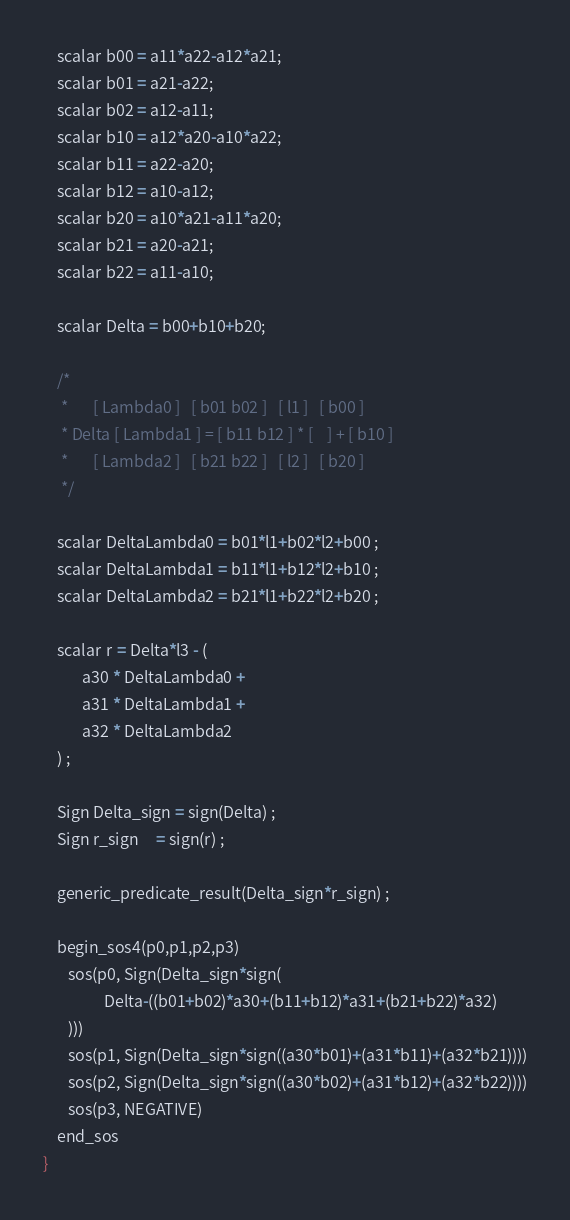Convert code to text. <code><loc_0><loc_0><loc_500><loc_500><_SQL_>
    scalar b00 = a11*a22-a12*a21;
    scalar b01 = a21-a22;
    scalar b02 = a12-a11;
    scalar b10 = a12*a20-a10*a22;
    scalar b11 = a22-a20;
    scalar b12 = a10-a12;
    scalar b20 = a10*a21-a11*a20;
    scalar b21 = a20-a21;
    scalar b22 = a11-a10;

    scalar Delta = b00+b10+b20;

    /*
     *       [ Lambda0 ]   [ b01 b02 ]   [ l1 ]   [ b00 ]
     * Delta [ Lambda1 ] = [ b11 b12 ] * [    ] + [ b10 ]
     *       [ Lambda2 ]   [ b21 b22 ]   [ l2 ]   [ b20 ]
     */

    scalar DeltaLambda0 = b01*l1+b02*l2+b00 ;
    scalar DeltaLambda1 = b11*l1+b12*l2+b10 ;
    scalar DeltaLambda2 = b21*l1+b22*l2+b20 ;

    scalar r = Delta*l3 - (
           a30 * DeltaLambda0 + 
           a31 * DeltaLambda1 +
           a32 * DeltaLambda2
    ) ;

    Sign Delta_sign = sign(Delta) ;
    Sign r_sign     = sign(r) ;

    generic_predicate_result(Delta_sign*r_sign) ;

    begin_sos4(p0,p1,p2,p3)
       sos(p0, Sign(Delta_sign*sign(
                 Delta-((b01+b02)*a30+(b11+b12)*a31+(b21+b22)*a32)
       )))
       sos(p1, Sign(Delta_sign*sign((a30*b01)+(a31*b11)+(a32*b21))))
       sos(p2, Sign(Delta_sign*sign((a30*b02)+(a31*b12)+(a32*b22))))
       sos(p3, NEGATIVE)
    end_sos
}
</code> 